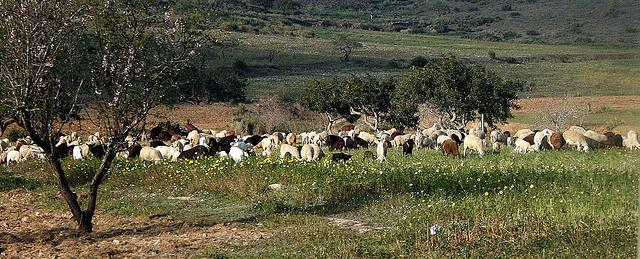What are the animals doing?

Choices:
A) running
B) sleeping
C) resting
D) working resting 